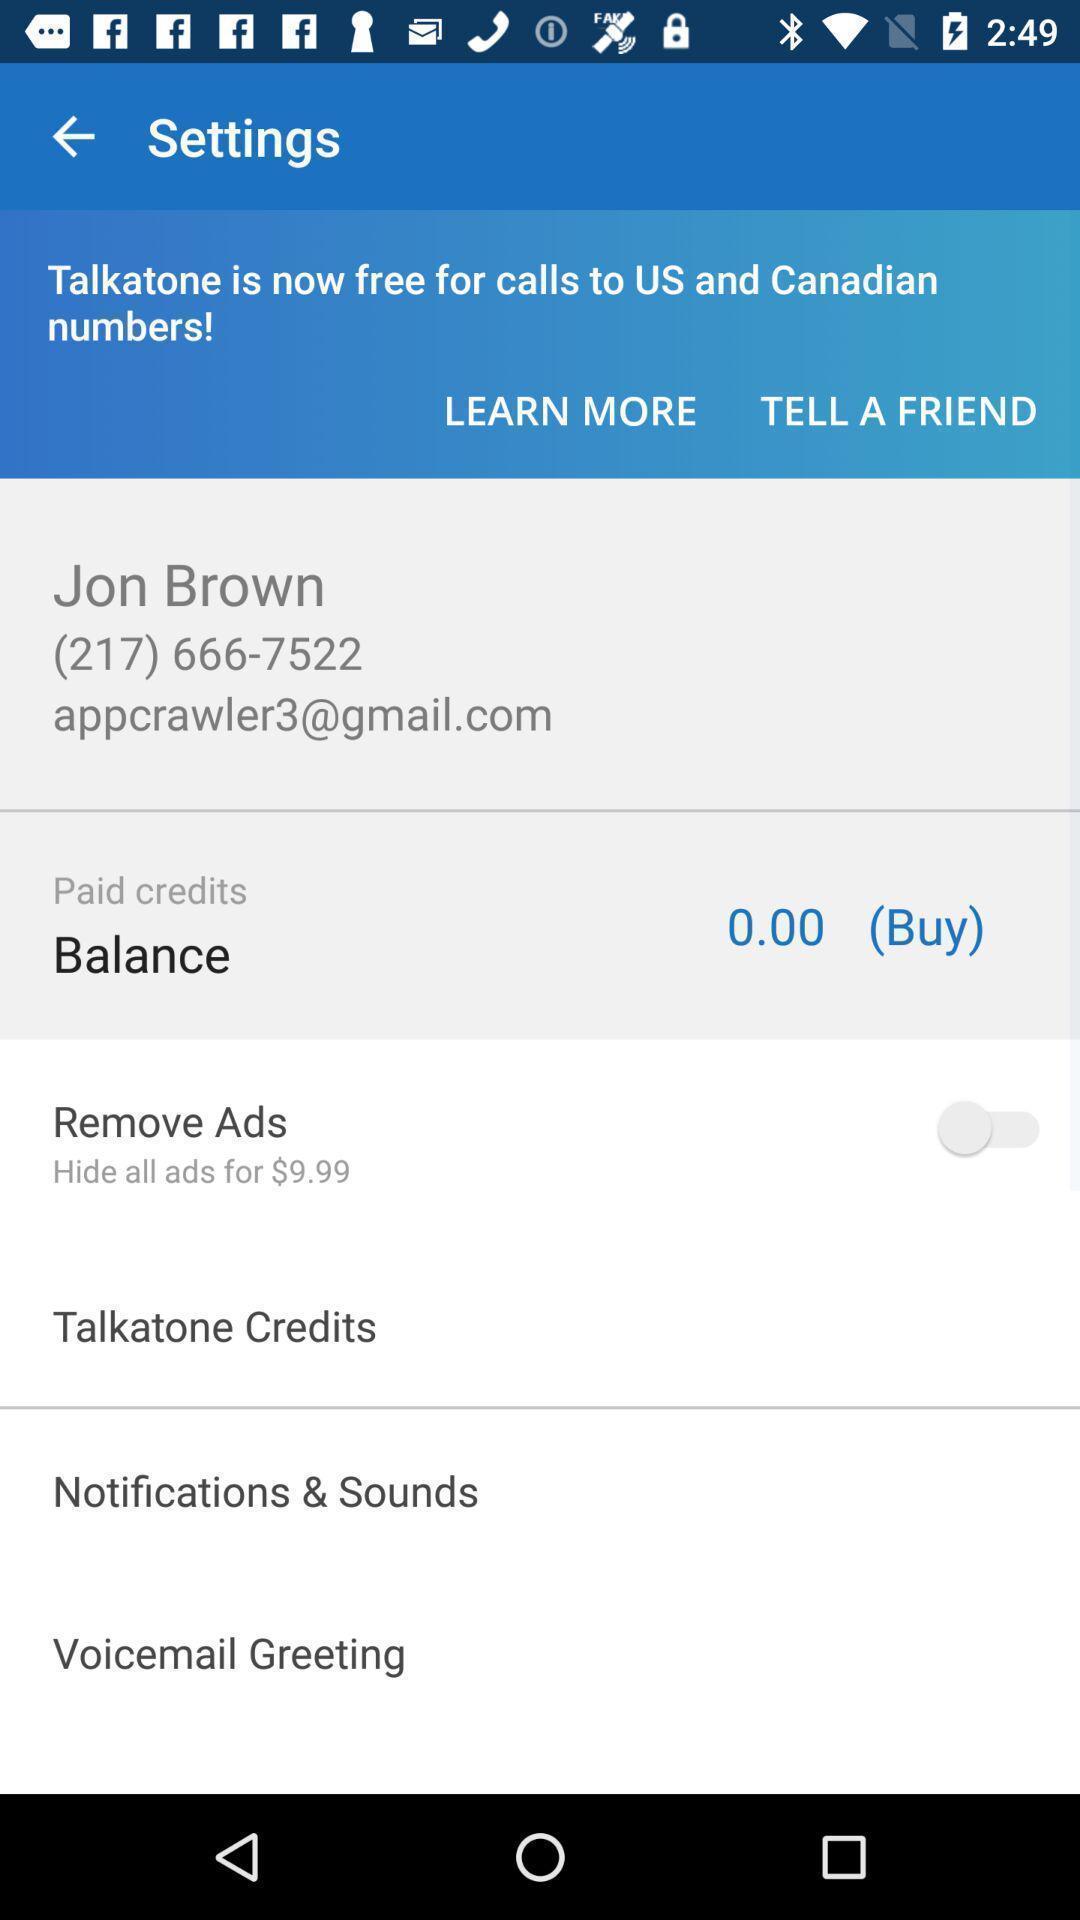Tell me about the visual elements in this screen capture. Settings page. 